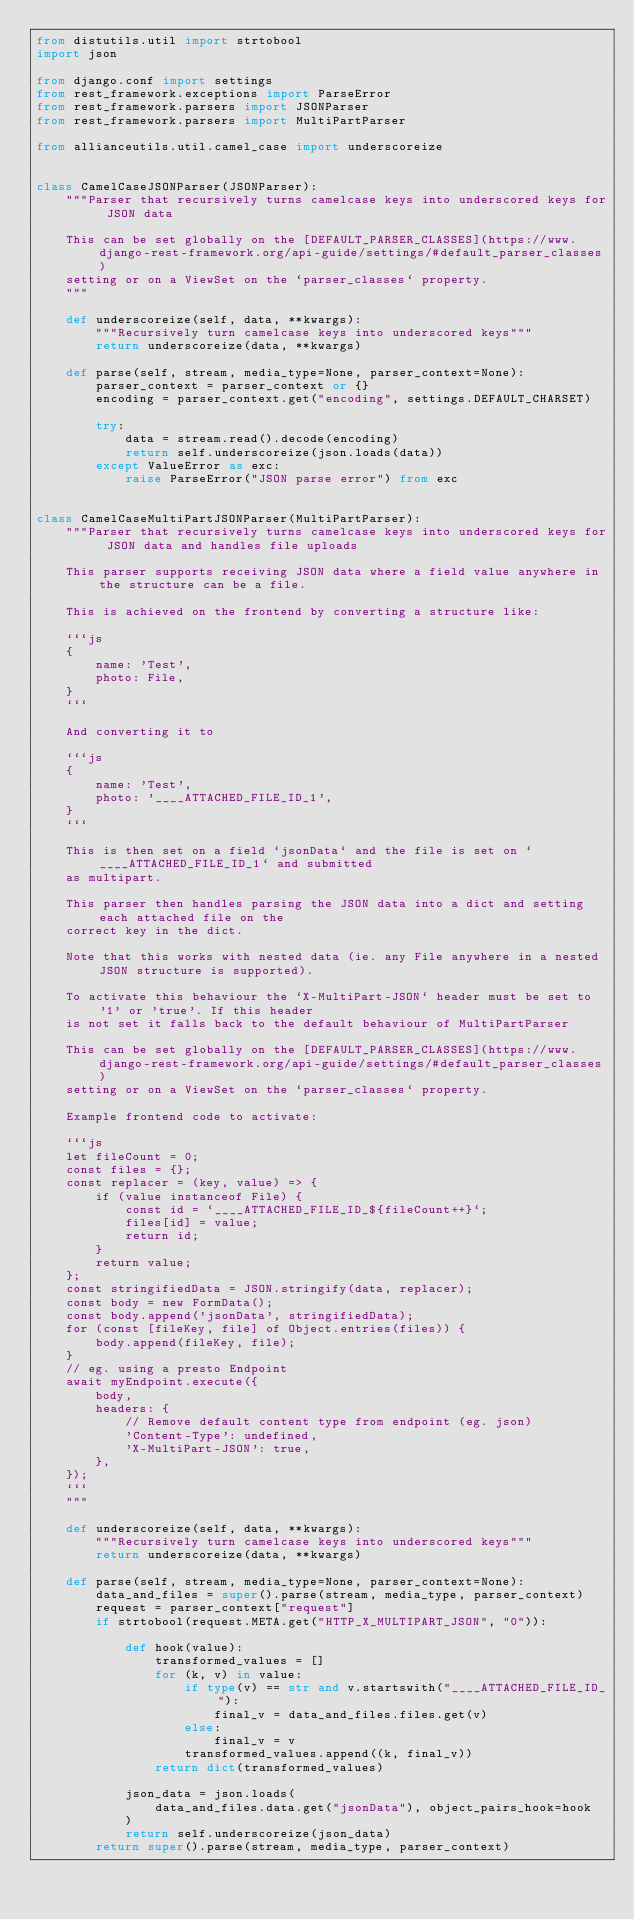Convert code to text. <code><loc_0><loc_0><loc_500><loc_500><_Python_>from distutils.util import strtobool
import json

from django.conf import settings
from rest_framework.exceptions import ParseError
from rest_framework.parsers import JSONParser
from rest_framework.parsers import MultiPartParser

from allianceutils.util.camel_case import underscoreize


class CamelCaseJSONParser(JSONParser):
    """Parser that recursively turns camelcase keys into underscored keys for JSON data

    This can be set globally on the [DEFAULT_PARSER_CLASSES](https://www.django-rest-framework.org/api-guide/settings/#default_parser_classes)
    setting or on a ViewSet on the `parser_classes` property.
    """

    def underscoreize(self, data, **kwargs):
        """Recursively turn camelcase keys into underscored keys"""
        return underscoreize(data, **kwargs)

    def parse(self, stream, media_type=None, parser_context=None):
        parser_context = parser_context or {}
        encoding = parser_context.get("encoding", settings.DEFAULT_CHARSET)

        try:
            data = stream.read().decode(encoding)
            return self.underscoreize(json.loads(data))
        except ValueError as exc:
            raise ParseError("JSON parse error") from exc


class CamelCaseMultiPartJSONParser(MultiPartParser):
    """Parser that recursively turns camelcase keys into underscored keys for JSON data and handles file uploads

    This parser supports receiving JSON data where a field value anywhere in the structure can be a file.

    This is achieved on the frontend by converting a structure like:

    ```js
    {
        name: 'Test',
        photo: File,
    }
    ```

    And converting it to

    ```js
    {
        name: 'Test',
        photo: '____ATTACHED_FILE_ID_1',
    }
    ```

    This is then set on a field `jsonData` and the file is set on `____ATTACHED_FILE_ID_1` and submitted
    as multipart.

    This parser then handles parsing the JSON data into a dict and setting each attached file on the
    correct key in the dict.

    Note that this works with nested data (ie. any File anywhere in a nested JSON structure is supported).

    To activate this behaviour the `X-MultiPart-JSON` header must be set to '1' or 'true'. If this header
    is not set it falls back to the default behaviour of MultiPartParser

    This can be set globally on the [DEFAULT_PARSER_CLASSES](https://www.django-rest-framework.org/api-guide/settings/#default_parser_classes)
    setting or on a ViewSet on the `parser_classes` property.

    Example frontend code to activate:

    ```js
    let fileCount = 0;
    const files = {};
    const replacer = (key, value) => {
        if (value instanceof File) {
            const id = `____ATTACHED_FILE_ID_${fileCount++}`;
            files[id] = value;
            return id;
        }
        return value;
    };
    const stringifiedData = JSON.stringify(data, replacer);
    const body = new FormData();
    const body.append('jsonData', stringifiedData);
    for (const [fileKey, file] of Object.entries(files)) {
        body.append(fileKey, file);
    }
    // eg. using a presto Endpoint
    await myEndpoint.execute({
        body,
        headers: {
            // Remove default content type from endpoint (eg. json)
            'Content-Type': undefined,
            'X-MultiPart-JSON': true,
        },
    });
    ```
    """

    def underscoreize(self, data, **kwargs):
        """Recursively turn camelcase keys into underscored keys"""
        return underscoreize(data, **kwargs)

    def parse(self, stream, media_type=None, parser_context=None):
        data_and_files = super().parse(stream, media_type, parser_context)
        request = parser_context["request"]
        if strtobool(request.META.get("HTTP_X_MULTIPART_JSON", "0")):

            def hook(value):
                transformed_values = []
                for (k, v) in value:
                    if type(v) == str and v.startswith("____ATTACHED_FILE_ID_"):
                        final_v = data_and_files.files.get(v)
                    else:
                        final_v = v
                    transformed_values.append((k, final_v))
                return dict(transformed_values)

            json_data = json.loads(
                data_and_files.data.get("jsonData"), object_pairs_hook=hook
            )
            return self.underscoreize(json_data)
        return super().parse(stream, media_type, parser_context)
</code> 